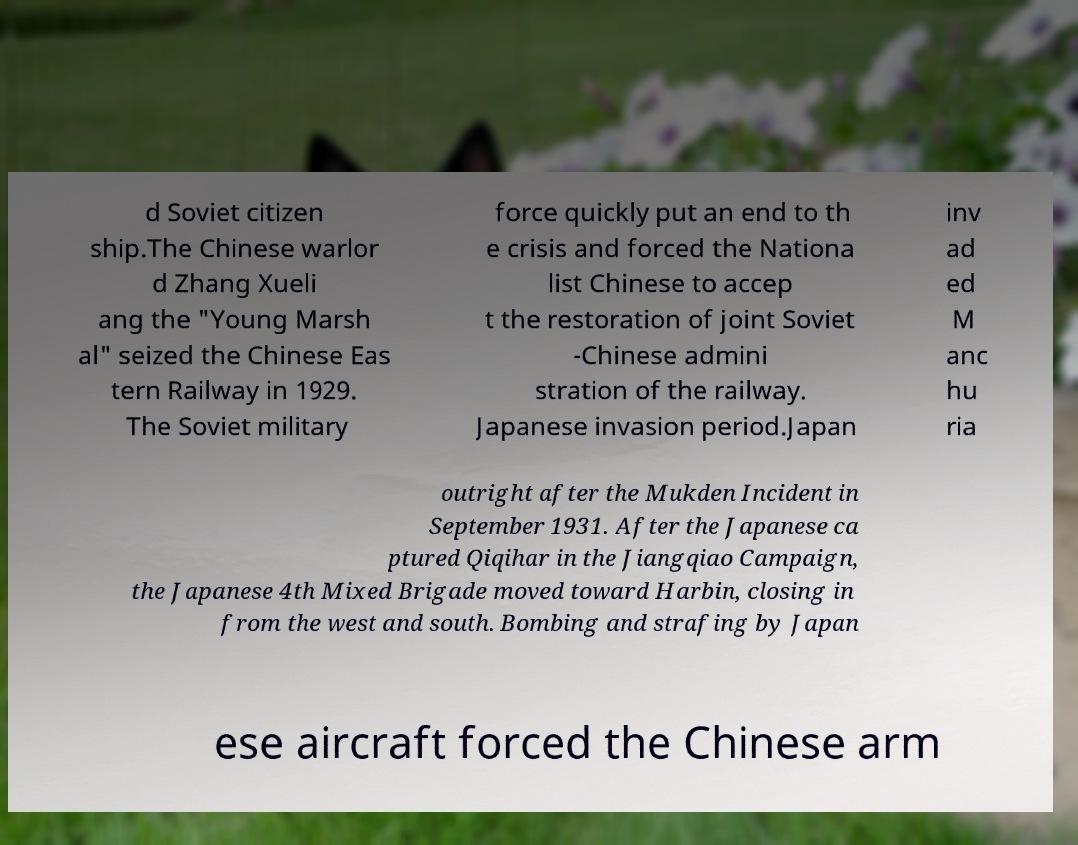What messages or text are displayed in this image? I need them in a readable, typed format. d Soviet citizen ship.The Chinese warlor d Zhang Xueli ang the "Young Marsh al" seized the Chinese Eas tern Railway in 1929. The Soviet military force quickly put an end to th e crisis and forced the Nationa list Chinese to accep t the restoration of joint Soviet -Chinese admini stration of the railway. Japanese invasion period.Japan inv ad ed M anc hu ria outright after the Mukden Incident in September 1931. After the Japanese ca ptured Qiqihar in the Jiangqiao Campaign, the Japanese 4th Mixed Brigade moved toward Harbin, closing in from the west and south. Bombing and strafing by Japan ese aircraft forced the Chinese arm 